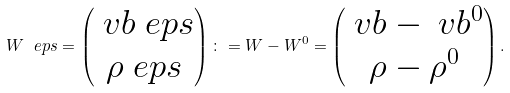Convert formula to latex. <formula><loc_0><loc_0><loc_500><loc_500>W ^ { \ } e p s = \left ( \begin{matrix} \ v b ^ { \ } e p s \\ \rho ^ { \ } e p s \end{matrix} \right ) \colon = W - W ^ { 0 } = \left ( \begin{matrix} \ v b - \ v b ^ { 0 } \\ \rho - \rho ^ { 0 } \end{matrix} \right ) .</formula> 